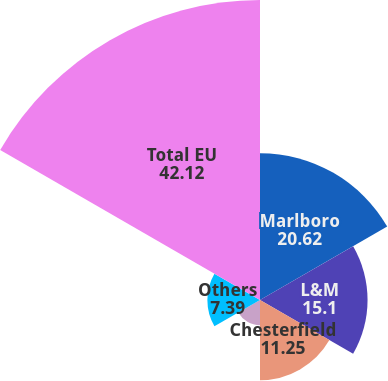Convert chart. <chart><loc_0><loc_0><loc_500><loc_500><pie_chart><fcel>Marlboro<fcel>L&M<fcel>Chesterfield<fcel>Philip Morris<fcel>Others<fcel>Total EU<nl><fcel>20.62%<fcel>15.1%<fcel>11.25%<fcel>3.53%<fcel>7.39%<fcel>42.12%<nl></chart> 